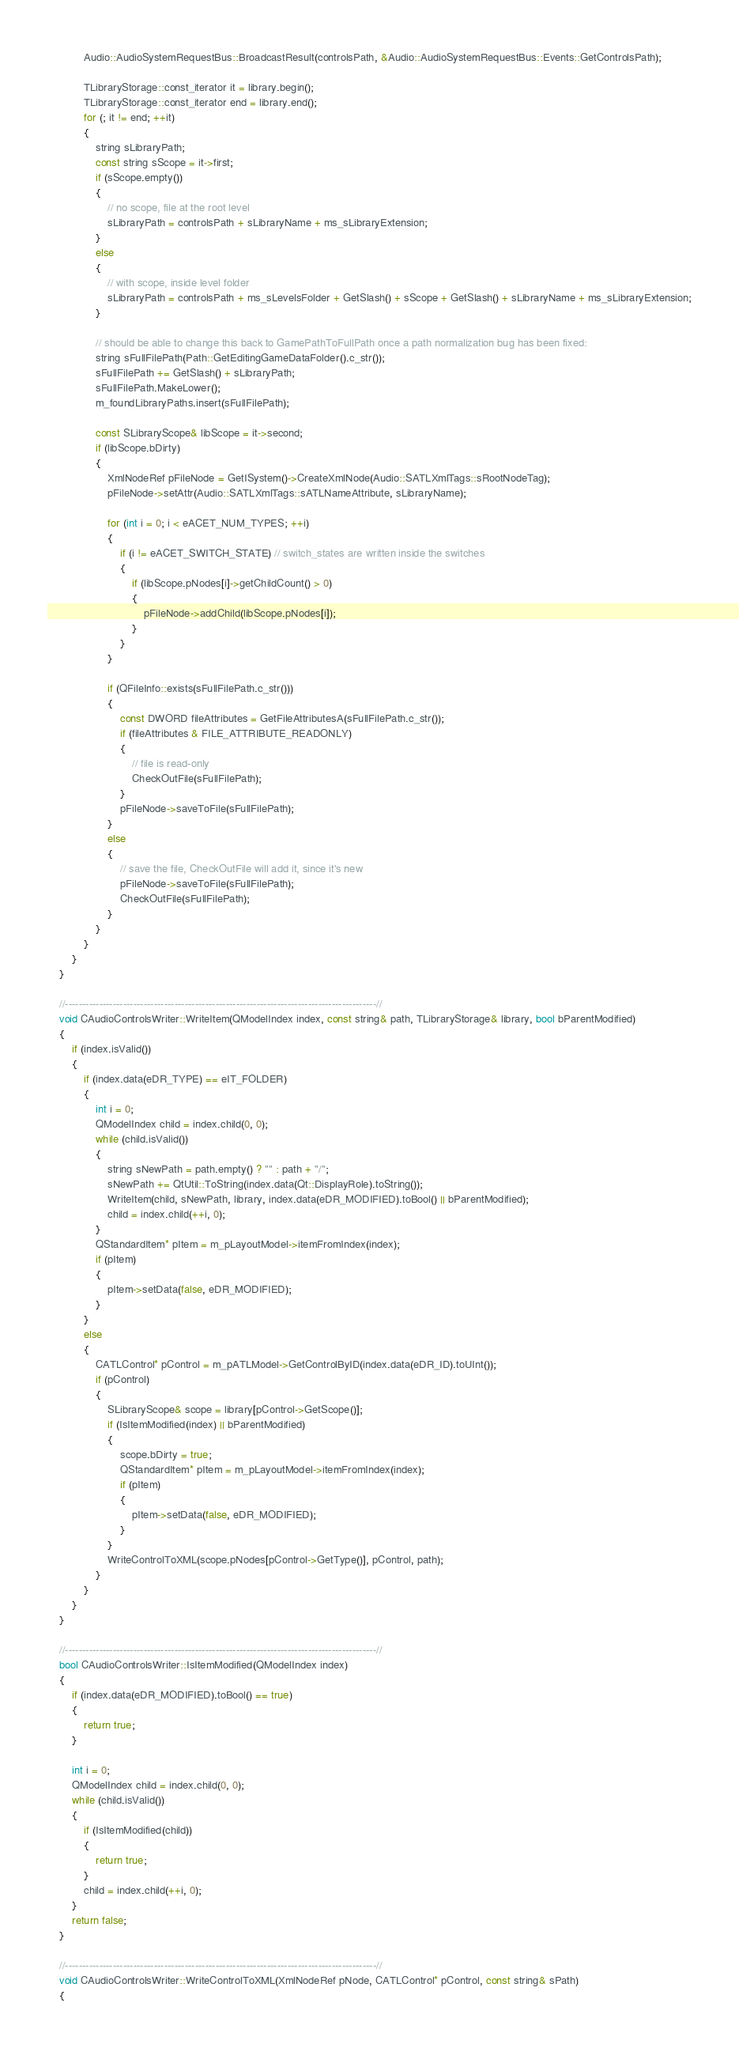<code> <loc_0><loc_0><loc_500><loc_500><_C++_>            Audio::AudioSystemRequestBus::BroadcastResult(controlsPath, &Audio::AudioSystemRequestBus::Events::GetControlsPath);

            TLibraryStorage::const_iterator it = library.begin();
            TLibraryStorage::const_iterator end = library.end();
            for (; it != end; ++it)
            {
                string sLibraryPath;
                const string sScope = it->first;
                if (sScope.empty())
                {
                    // no scope, file at the root level
                    sLibraryPath = controlsPath + sLibraryName + ms_sLibraryExtension;
                }
                else
                {
                    // with scope, inside level folder
                    sLibraryPath = controlsPath + ms_sLevelsFolder + GetSlash() + sScope + GetSlash() + sLibraryName + ms_sLibraryExtension;
                }

                // should be able to change this back to GamePathToFullPath once a path normalization bug has been fixed:
                string sFullFilePath(Path::GetEditingGameDataFolder().c_str());
                sFullFilePath += GetSlash() + sLibraryPath;
                sFullFilePath.MakeLower();
                m_foundLibraryPaths.insert(sFullFilePath);

                const SLibraryScope& libScope = it->second;
                if (libScope.bDirty)
                {
                    XmlNodeRef pFileNode = GetISystem()->CreateXmlNode(Audio::SATLXmlTags::sRootNodeTag);
                    pFileNode->setAttr(Audio::SATLXmlTags::sATLNameAttribute, sLibraryName);

                    for (int i = 0; i < eACET_NUM_TYPES; ++i)
                    {
                        if (i != eACET_SWITCH_STATE) // switch_states are written inside the switches
                        {
                            if (libScope.pNodes[i]->getChildCount() > 0)
                            {
                                pFileNode->addChild(libScope.pNodes[i]);
                            }
                        }
                    }

                    if (QFileInfo::exists(sFullFilePath.c_str()))
                    {
                        const DWORD fileAttributes = GetFileAttributesA(sFullFilePath.c_str());
                        if (fileAttributes & FILE_ATTRIBUTE_READONLY)
                        {
                            // file is read-only
                            CheckOutFile(sFullFilePath);
                        }
                        pFileNode->saveToFile(sFullFilePath);
                    }
                    else
                    {
                        // save the file, CheckOutFile will add it, since it's new
                        pFileNode->saveToFile(sFullFilePath);
                        CheckOutFile(sFullFilePath);
                    }
                }
            }
        }
    }

    //-------------------------------------------------------------------------------------------//
    void CAudioControlsWriter::WriteItem(QModelIndex index, const string& path, TLibraryStorage& library, bool bParentModified)
    {
        if (index.isValid())
        {
            if (index.data(eDR_TYPE) == eIT_FOLDER)
            {
                int i = 0;
                QModelIndex child = index.child(0, 0);
                while (child.isValid())
                {
                    string sNewPath = path.empty() ? "" : path + "/";
                    sNewPath += QtUtil::ToString(index.data(Qt::DisplayRole).toString());
                    WriteItem(child, sNewPath, library, index.data(eDR_MODIFIED).toBool() || bParentModified);
                    child = index.child(++i, 0);
                }
                QStandardItem* pItem = m_pLayoutModel->itemFromIndex(index);
                if (pItem)
                {
                    pItem->setData(false, eDR_MODIFIED);
                }
            }
            else
            {
                CATLControl* pControl = m_pATLModel->GetControlByID(index.data(eDR_ID).toUInt());
                if (pControl)
                {
                    SLibraryScope& scope = library[pControl->GetScope()];
                    if (IsItemModified(index) || bParentModified)
                    {
                        scope.bDirty = true;
                        QStandardItem* pItem = m_pLayoutModel->itemFromIndex(index);
                        if (pItem)
                        {
                            pItem->setData(false, eDR_MODIFIED);
                        }
                    }
                    WriteControlToXML(scope.pNodes[pControl->GetType()], pControl, path);
                }
            }
        }
    }

    //-------------------------------------------------------------------------------------------//
    bool CAudioControlsWriter::IsItemModified(QModelIndex index)
    {
        if (index.data(eDR_MODIFIED).toBool() == true)
        {
            return true;
        }

        int i = 0;
        QModelIndex child = index.child(0, 0);
        while (child.isValid())
        {
            if (IsItemModified(child))
            {
                return true;
            }
            child = index.child(++i, 0);
        }
        return false;
    }

    //-------------------------------------------------------------------------------------------//
    void CAudioControlsWriter::WriteControlToXML(XmlNodeRef pNode, CATLControl* pControl, const string& sPath)
    {</code> 